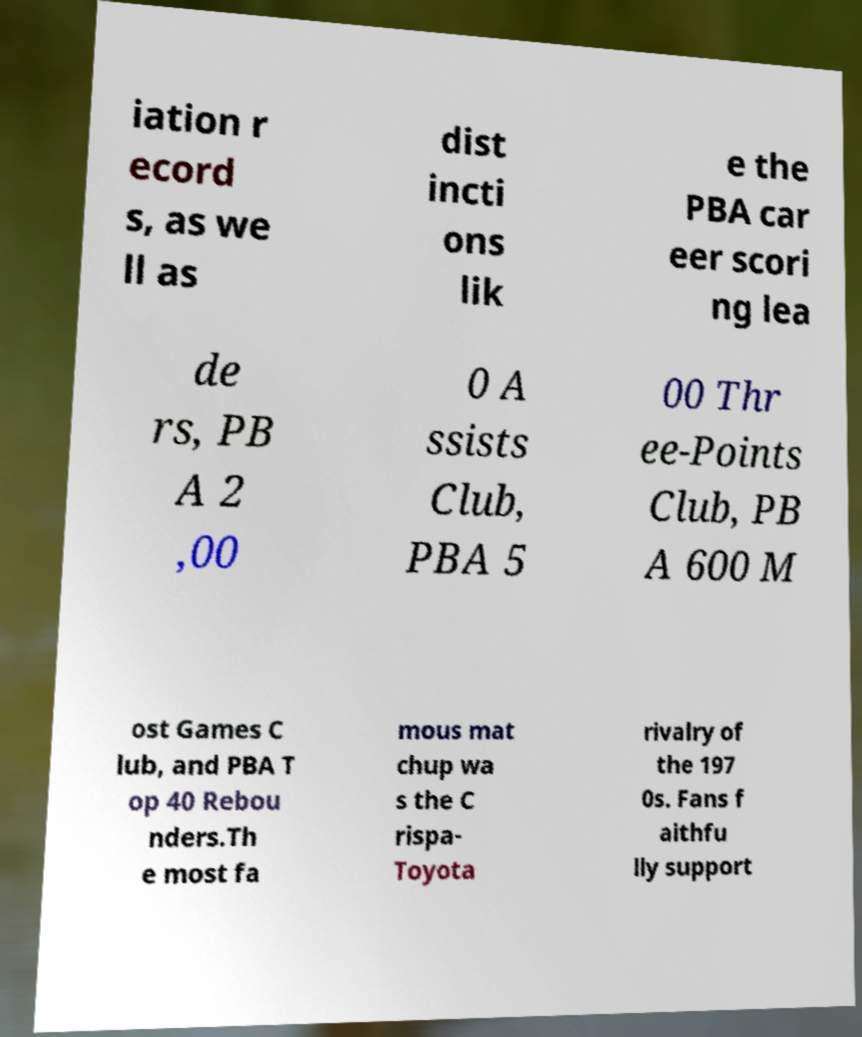Could you assist in decoding the text presented in this image and type it out clearly? iation r ecord s, as we ll as dist incti ons lik e the PBA car eer scori ng lea de rs, PB A 2 ,00 0 A ssists Club, PBA 5 00 Thr ee-Points Club, PB A 600 M ost Games C lub, and PBA T op 40 Rebou nders.Th e most fa mous mat chup wa s the C rispa- Toyota rivalry of the 197 0s. Fans f aithfu lly support 